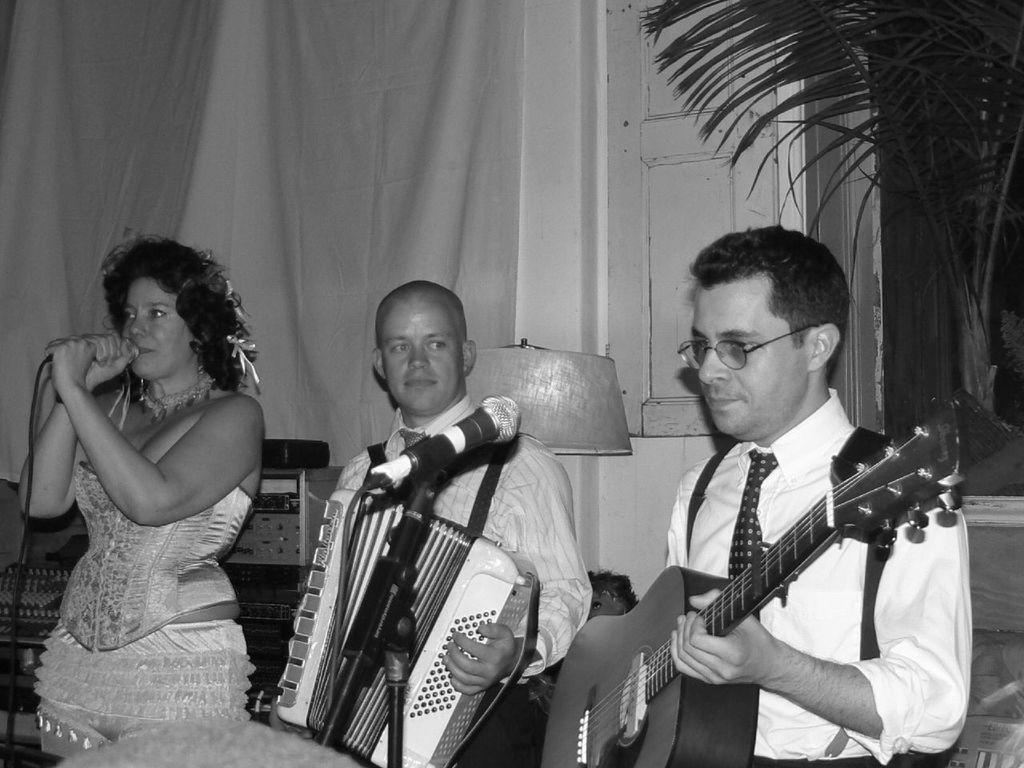Could you give a brief overview of what you see in this image? A black and white picture. This woman is holding a mic. This man and this man are playing musical instruments in-front of mic. This is a plant. This is an electronic device. This is an lantern lamp. 